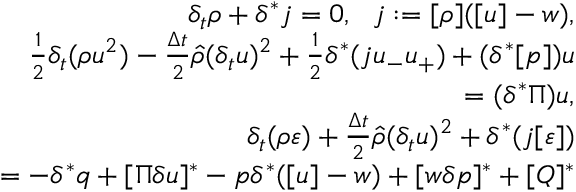Convert formula to latex. <formula><loc_0><loc_0><loc_500><loc_500>\begin{array} { r } { \delta _ { t } \rho + \delta ^ { * } j = 0 , \ \ j \colon = [ \rho ] ( [ u ] - w ) , } \\ { \frac { 1 } { 2 } \delta _ { t } ( \rho u ^ { 2 } ) - \frac { \Delta t } { 2 } \hat { \rho } ( \delta _ { t } u ) ^ { 2 } + \frac { 1 } { 2 } \delta ^ { * } ( j u _ { - } u _ { + } ) + ( \delta ^ { * } [ p ] ) u } \\ { = ( \delta ^ { * } \Pi ) u , } \\ { \delta _ { t } ( \rho \varepsilon ) + \frac { \Delta t } { 2 } \hat { \rho } ( \delta _ { t } u ) ^ { 2 } + \delta ^ { * } ( j [ \varepsilon ] ) } \\ { = - \delta ^ { * } q + [ \Pi \delta u ] ^ { * } - p \delta ^ { * } ( [ u ] - w ) + [ w \delta p ] ^ { * } + [ Q ] ^ { * } } \end{array}</formula> 